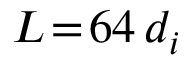<formula> <loc_0><loc_0><loc_500><loc_500>L \, = \, 6 4 \, d _ { i }</formula> 